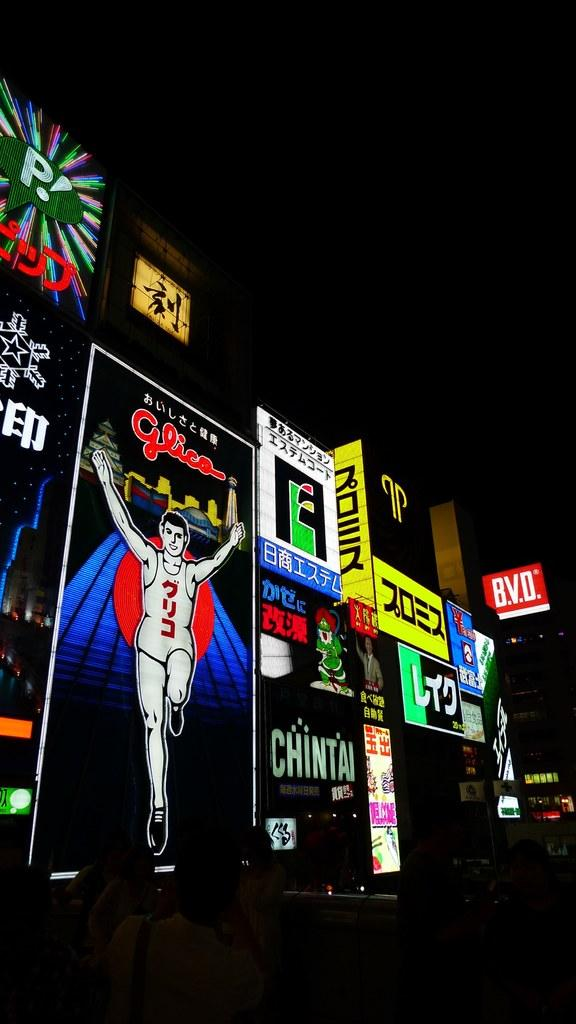Provide a one-sentence caption for the provided image. Many brightly lit Japanese advertisements for things like Chintai line the street. 